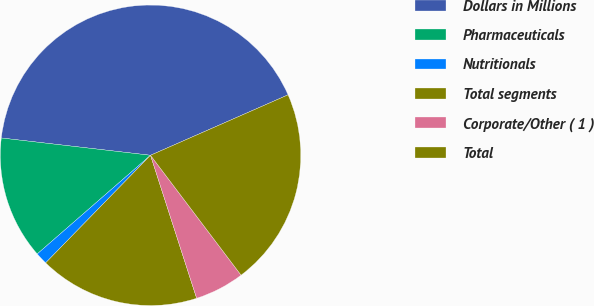Convert chart. <chart><loc_0><loc_0><loc_500><loc_500><pie_chart><fcel>Dollars in Millions<fcel>Pharmaceuticals<fcel>Nutritionals<fcel>Total segments<fcel>Corporate/Other ( 1 )<fcel>Total<nl><fcel>41.57%<fcel>13.24%<fcel>1.3%<fcel>17.26%<fcel>5.33%<fcel>21.29%<nl></chart> 